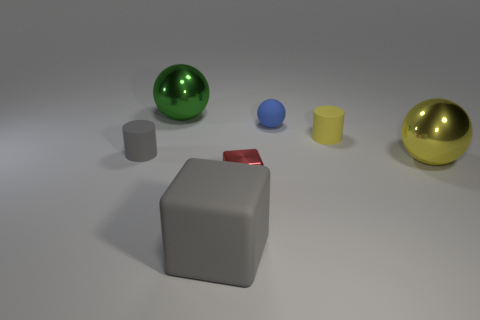Subtract all big balls. How many balls are left? 1 Add 2 large green rubber cubes. How many objects exist? 9 Subtract all yellow balls. How many balls are left? 2 Subtract 0 purple balls. How many objects are left? 7 Subtract all cylinders. How many objects are left? 5 Subtract all red cylinders. Subtract all brown blocks. How many cylinders are left? 2 Subtract all green spheres. Subtract all big yellow objects. How many objects are left? 5 Add 1 large gray objects. How many large gray objects are left? 2 Add 7 red blocks. How many red blocks exist? 8 